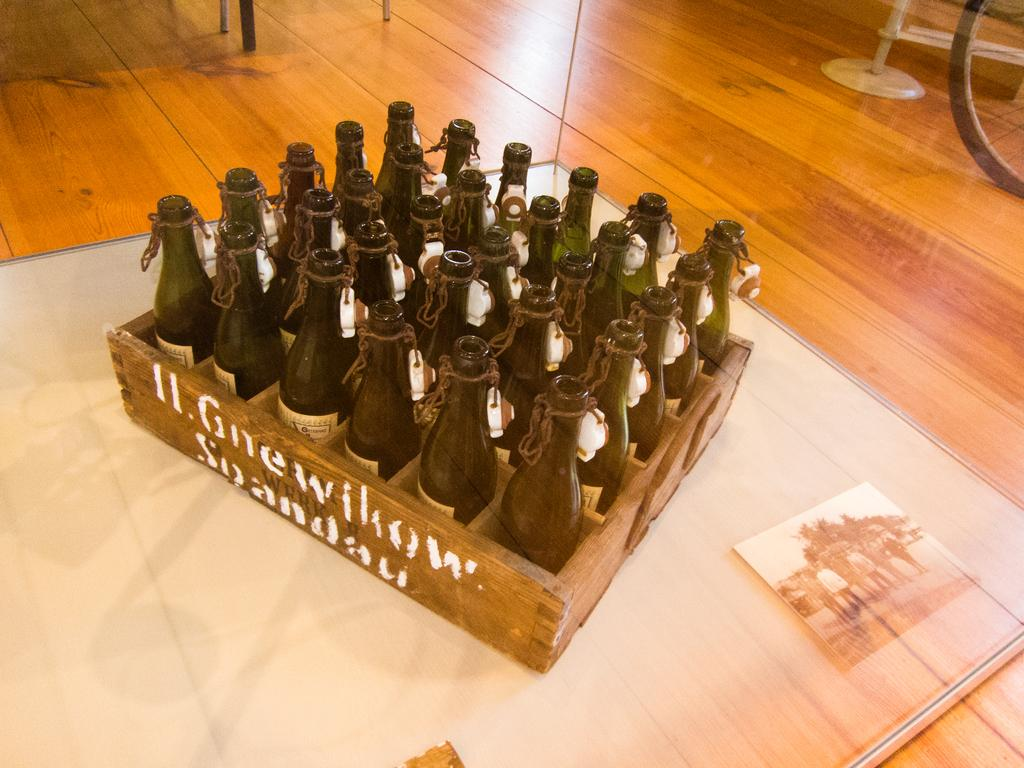<image>
Share a concise interpretation of the image provided. a box of empty bottles with words H Gnewikow on it 